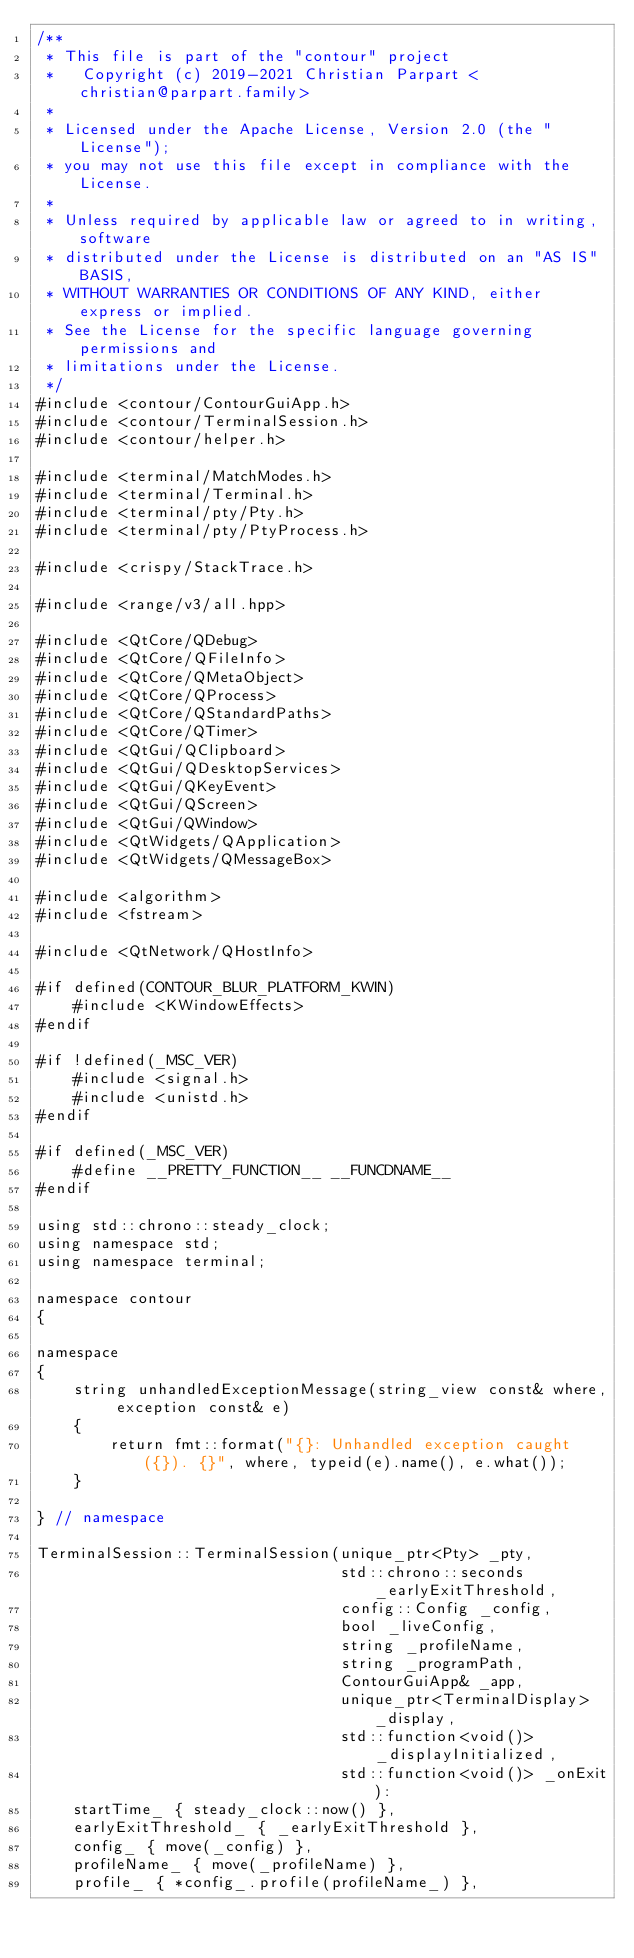<code> <loc_0><loc_0><loc_500><loc_500><_C++_>/**
 * This file is part of the "contour" project
 *   Copyright (c) 2019-2021 Christian Parpart <christian@parpart.family>
 *
 * Licensed under the Apache License, Version 2.0 (the "License");
 * you may not use this file except in compliance with the License.
 *
 * Unless required by applicable law or agreed to in writing, software
 * distributed under the License is distributed on an "AS IS" BASIS,
 * WITHOUT WARRANTIES OR CONDITIONS OF ANY KIND, either express or implied.
 * See the License for the specific language governing permissions and
 * limitations under the License.
 */
#include <contour/ContourGuiApp.h>
#include <contour/TerminalSession.h>
#include <contour/helper.h>

#include <terminal/MatchModes.h>
#include <terminal/Terminal.h>
#include <terminal/pty/Pty.h>
#include <terminal/pty/PtyProcess.h>

#include <crispy/StackTrace.h>

#include <range/v3/all.hpp>

#include <QtCore/QDebug>
#include <QtCore/QFileInfo>
#include <QtCore/QMetaObject>
#include <QtCore/QProcess>
#include <QtCore/QStandardPaths>
#include <QtCore/QTimer>
#include <QtGui/QClipboard>
#include <QtGui/QDesktopServices>
#include <QtGui/QKeyEvent>
#include <QtGui/QScreen>
#include <QtGui/QWindow>
#include <QtWidgets/QApplication>
#include <QtWidgets/QMessageBox>

#include <algorithm>
#include <fstream>

#include <QtNetwork/QHostInfo>

#if defined(CONTOUR_BLUR_PLATFORM_KWIN)
    #include <KWindowEffects>
#endif

#if !defined(_MSC_VER)
    #include <signal.h>
    #include <unistd.h>
#endif

#if defined(_MSC_VER)
    #define __PRETTY_FUNCTION__ __FUNCDNAME__
#endif

using std::chrono::steady_clock;
using namespace std;
using namespace terminal;

namespace contour
{

namespace
{
    string unhandledExceptionMessage(string_view const& where, exception const& e)
    {
        return fmt::format("{}: Unhandled exception caught ({}). {}", where, typeid(e).name(), e.what());
    }

} // namespace

TerminalSession::TerminalSession(unique_ptr<Pty> _pty,
                                 std::chrono::seconds _earlyExitThreshold,
                                 config::Config _config,
                                 bool _liveConfig,
                                 string _profileName,
                                 string _programPath,
                                 ContourGuiApp& _app,
                                 unique_ptr<TerminalDisplay> _display,
                                 std::function<void()> _displayInitialized,
                                 std::function<void()> _onExit):
    startTime_ { steady_clock::now() },
    earlyExitThreshold_ { _earlyExitThreshold },
    config_ { move(_config) },
    profileName_ { move(_profileName) },
    profile_ { *config_.profile(profileName_) },</code> 